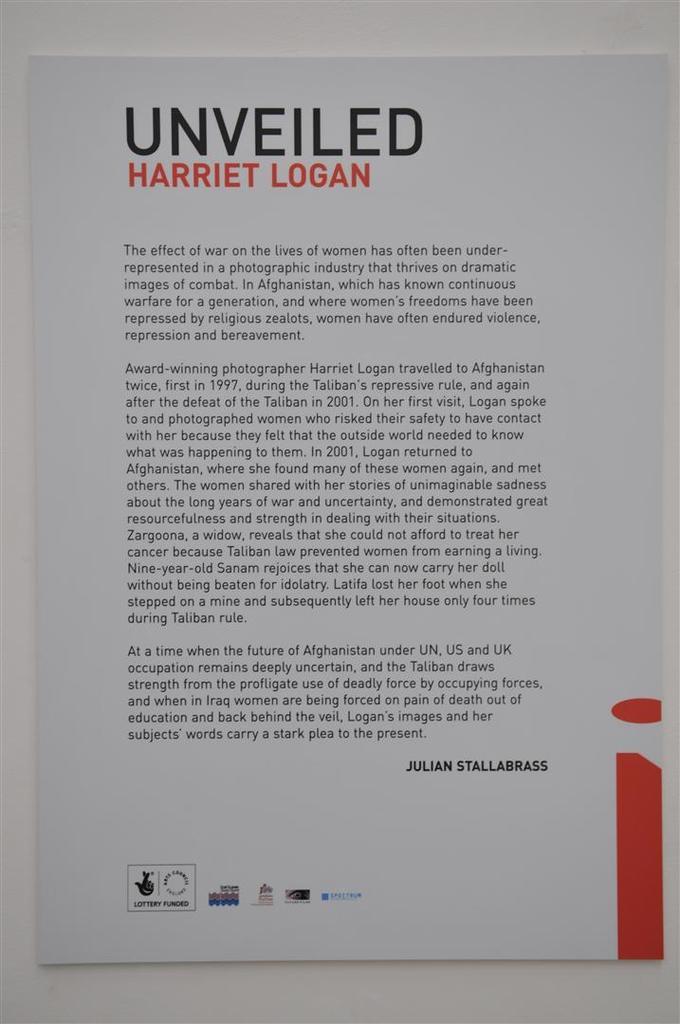What name is written in the red?
Your response must be concise. Harriet logan. What is the title of the article?
Your response must be concise. Unveiled. 